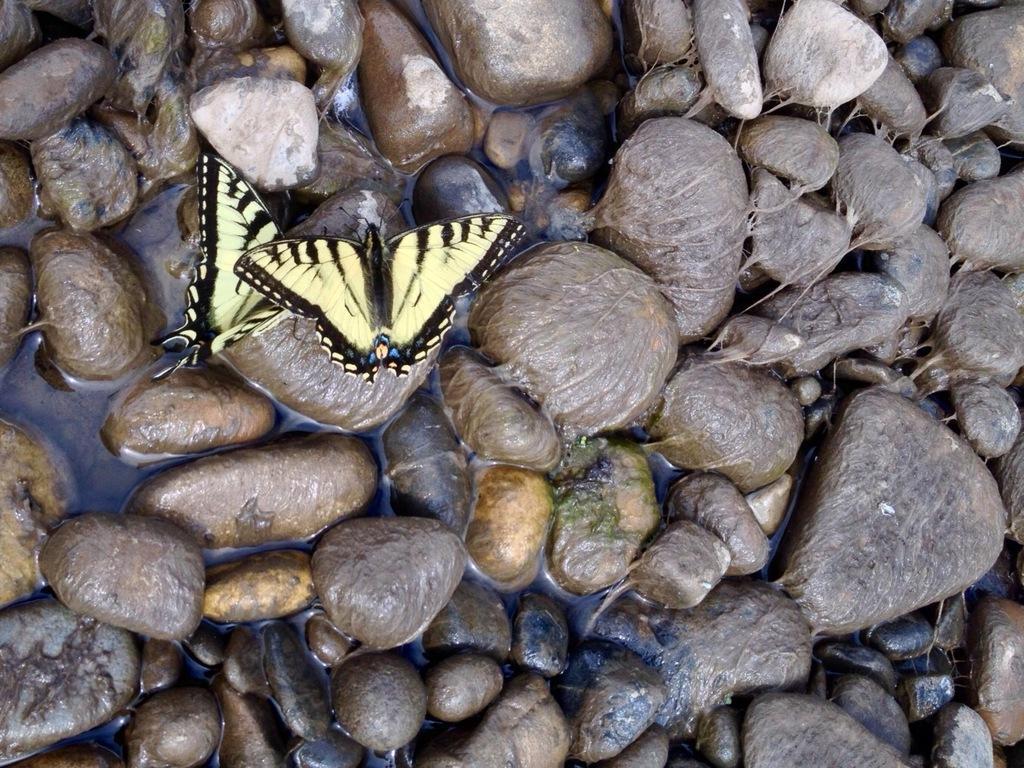How would you summarize this image in a sentence or two? In this picture we can see butterflies, pebbles and water. 